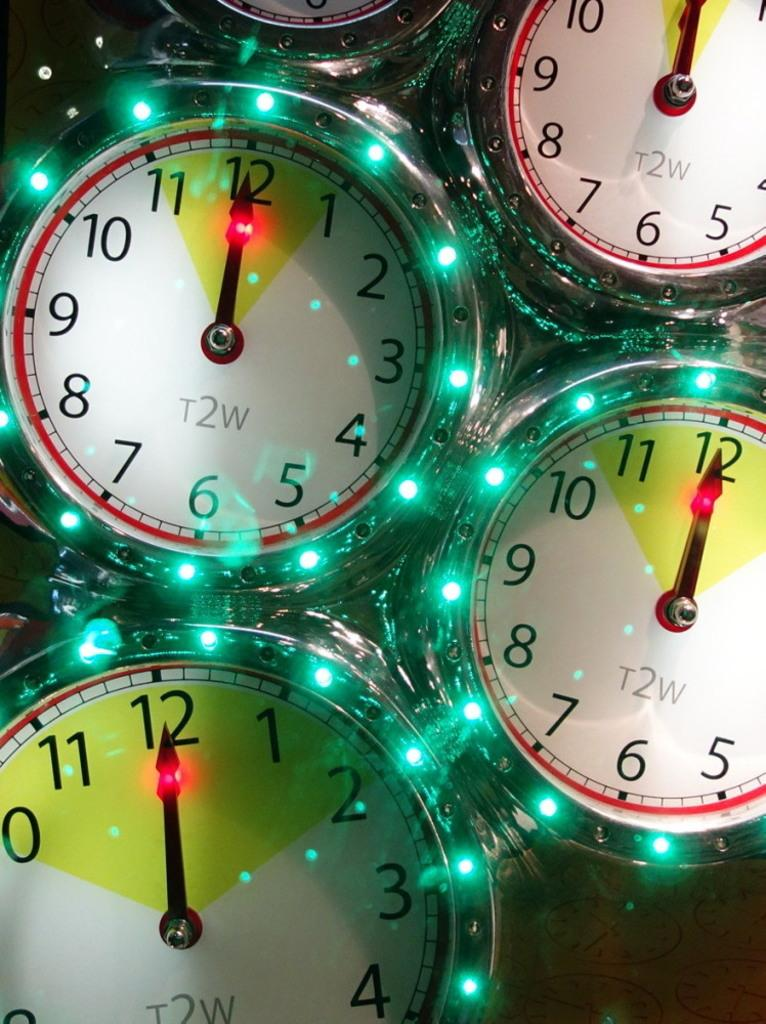<image>
Share a concise interpretation of the image provided. the numbers 1 to 12 that are on the watches 